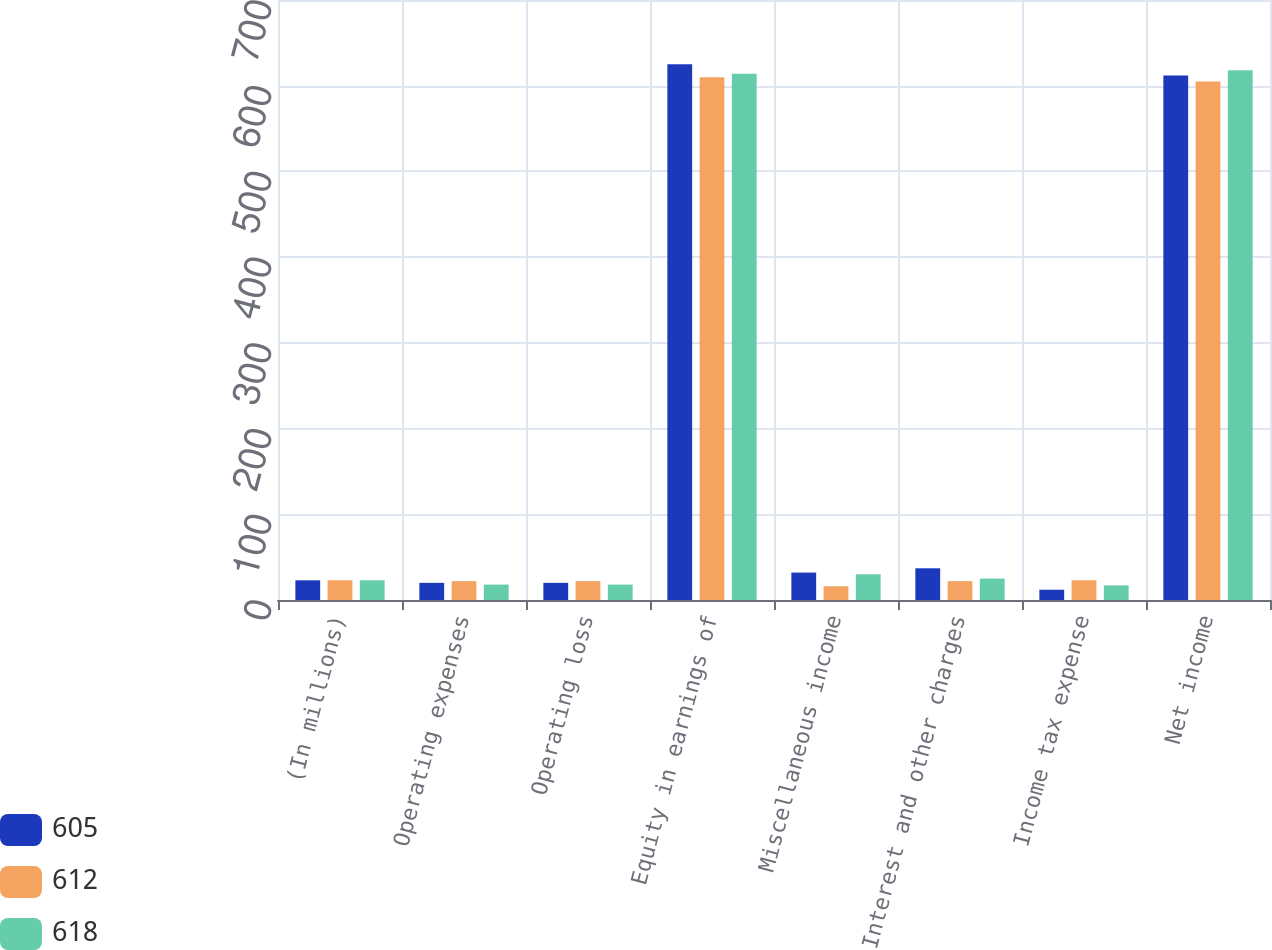<chart> <loc_0><loc_0><loc_500><loc_500><stacked_bar_chart><ecel><fcel>(In millions)<fcel>Operating expenses<fcel>Operating loss<fcel>Equity in earnings of<fcel>Miscellaneous income<fcel>Interest and other charges<fcel>Income tax expense<fcel>Net income<nl><fcel>605<fcel>23<fcel>20<fcel>20<fcel>625<fcel>32<fcel>37<fcel>12<fcel>612<nl><fcel>612<fcel>23<fcel>22<fcel>22<fcel>610<fcel>16<fcel>22<fcel>23<fcel>605<nl><fcel>618<fcel>23<fcel>18<fcel>18<fcel>614<fcel>30<fcel>25<fcel>17<fcel>618<nl></chart> 